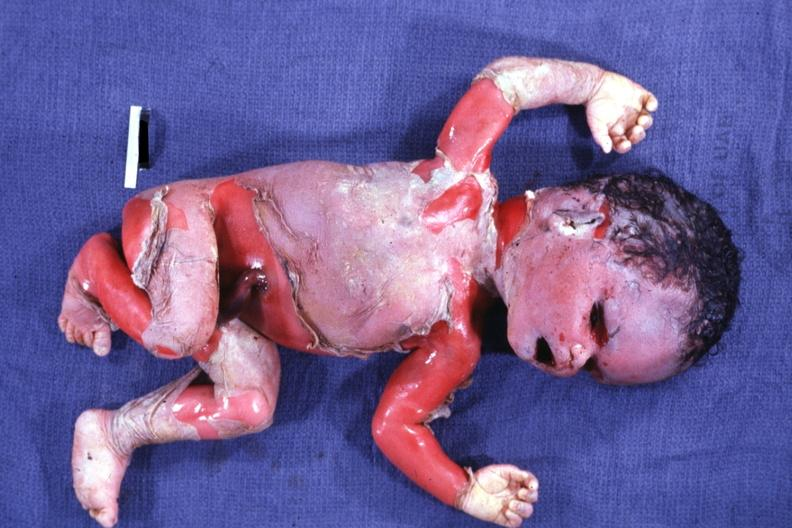does sacrococcygeal teratoma show external view of advanced state?
Answer the question using a single word or phrase. No 